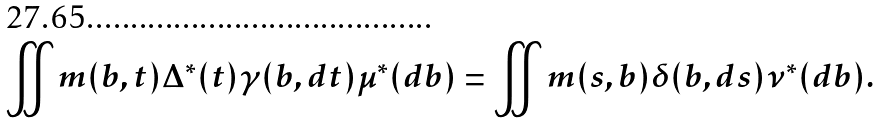Convert formula to latex. <formula><loc_0><loc_0><loc_500><loc_500>\iint m ( b , t ) \Delta ^ { * } ( t ) \gamma ( b , d t ) \mu ^ { * } ( d b ) = \iint m ( s , b ) \delta ( b , d s ) \nu ^ { * } ( d b ) .</formula> 